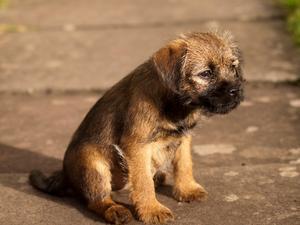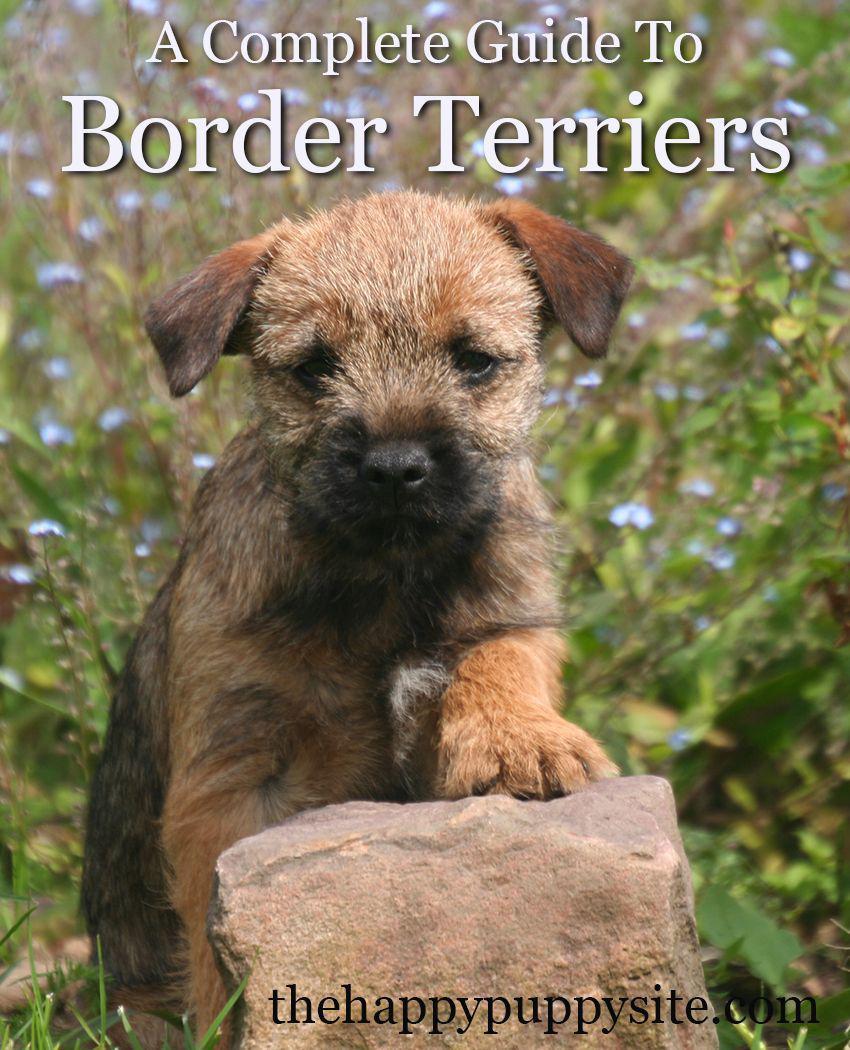The first image is the image on the left, the second image is the image on the right. For the images shown, is this caption "In at least one image there is a single dog sitting facing right forward." true? Answer yes or no. Yes. The first image is the image on the left, the second image is the image on the right. Analyze the images presented: Is the assertion "The puppy on the left is running, while the one on the right is not." valid? Answer yes or no. No. 